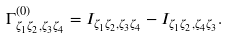<formula> <loc_0><loc_0><loc_500><loc_500>\Gamma ^ { ( 0 ) } _ { \zeta _ { 1 } \zeta _ { 2 } , \zeta _ { 3 } \zeta _ { 4 } } = I _ { \zeta _ { 1 } \zeta _ { 2 } , \zeta _ { 3 } \zeta _ { 4 } } - I _ { \zeta _ { 1 } \zeta _ { 2 } , \zeta _ { 4 } \zeta _ { 3 } } .</formula> 